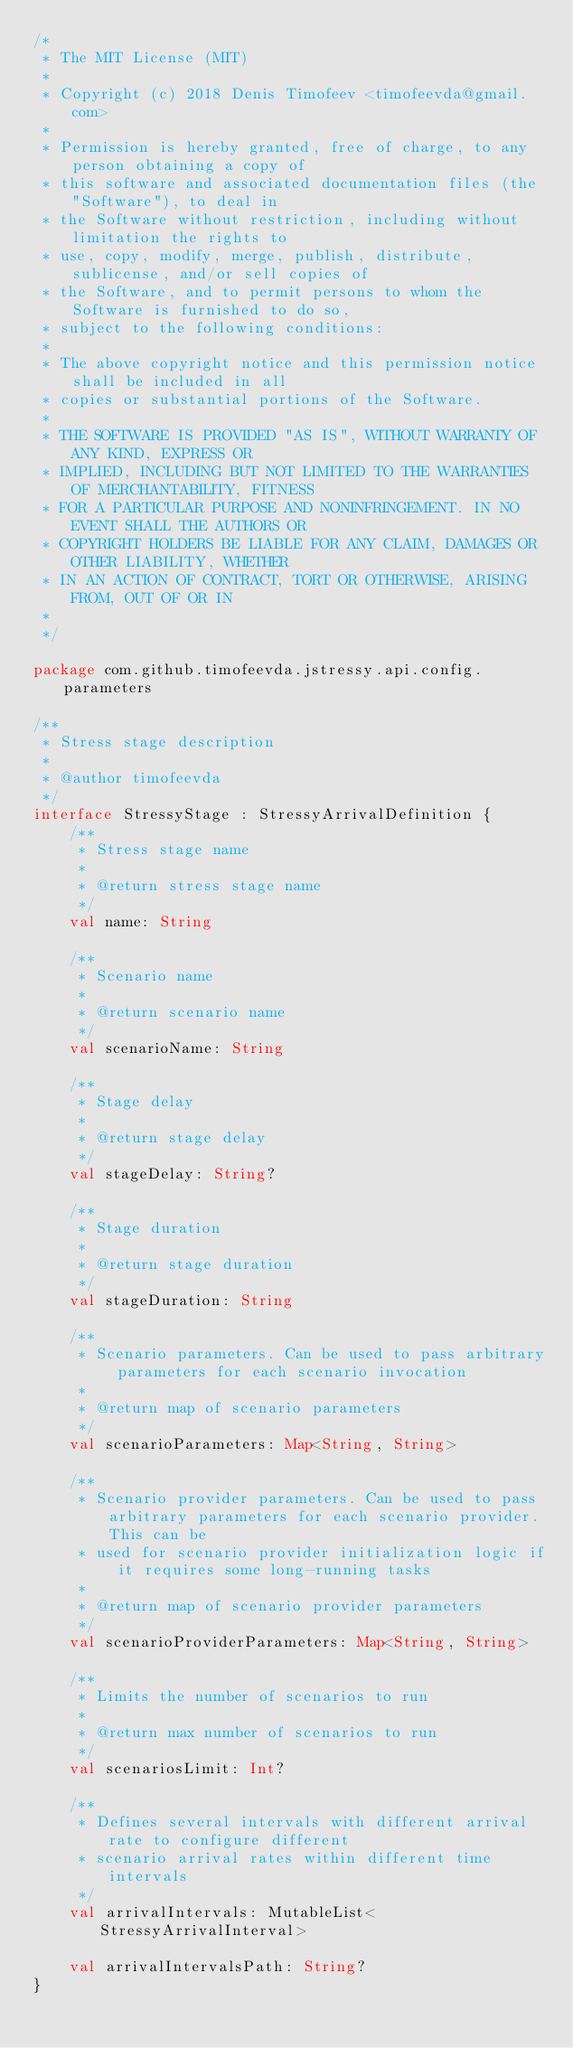Convert code to text. <code><loc_0><loc_0><loc_500><loc_500><_Kotlin_>/*
 * The MIT License (MIT)
 *
 * Copyright (c) 2018 Denis Timofeev <timofeevda@gmail.com>
 *
 * Permission is hereby granted, free of charge, to any person obtaining a copy of
 * this software and associated documentation files (the "Software"), to deal in
 * the Software without restriction, including without limitation the rights to
 * use, copy, modify, merge, publish, distribute, sublicense, and/or sell copies of
 * the Software, and to permit persons to whom the Software is furnished to do so,
 * subject to the following conditions:
 *
 * The above copyright notice and this permission notice shall be included in all
 * copies or substantial portions of the Software.
 *
 * THE SOFTWARE IS PROVIDED "AS IS", WITHOUT WARRANTY OF ANY KIND, EXPRESS OR
 * IMPLIED, INCLUDING BUT NOT LIMITED TO THE WARRANTIES OF MERCHANTABILITY, FITNESS
 * FOR A PARTICULAR PURPOSE AND NONINFRINGEMENT. IN NO EVENT SHALL THE AUTHORS OR
 * COPYRIGHT HOLDERS BE LIABLE FOR ANY CLAIM, DAMAGES OR OTHER LIABILITY, WHETHER
 * IN AN ACTION OF CONTRACT, TORT OR OTHERWISE, ARISING FROM, OUT OF OR IN
 *
 */

package com.github.timofeevda.jstressy.api.config.parameters

/**
 * Stress stage description
 *
 * @author timofeevda
 */
interface StressyStage : StressyArrivalDefinition {
    /**
     * Stress stage name
     *
     * @return stress stage name
     */
    val name: String

    /**
     * Scenario name
     *
     * @return scenario name
     */
    val scenarioName: String

    /**
     * Stage delay
     *
     * @return stage delay
     */
    val stageDelay: String?

    /**
     * Stage duration
     *
     * @return stage duration
     */
    val stageDuration: String

    /**
     * Scenario parameters. Can be used to pass arbitrary parameters for each scenario invocation
     *
     * @return map of scenario parameters
     */
    val scenarioParameters: Map<String, String>

    /**
     * Scenario provider parameters. Can be used to pass arbitrary parameters for each scenario provider. This can be
     * used for scenario provider initialization logic if it requires some long-running tasks
     *
     * @return map of scenario provider parameters
     */
    val scenarioProviderParameters: Map<String, String>

    /**
     * Limits the number of scenarios to run
     *
     * @return max number of scenarios to run
     */
    val scenariosLimit: Int?

    /**
     * Defines several intervals with different arrival rate to configure different
     * scenario arrival rates within different time intervals
     */
    val arrivalIntervals: MutableList<StressyArrivalInterval>

    val arrivalIntervalsPath: String?
}
</code> 